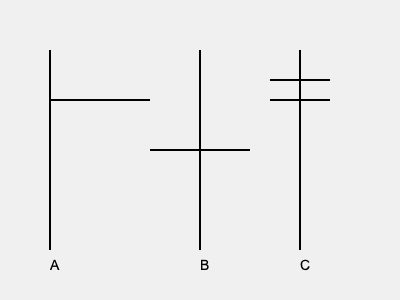In the image above, three different types of crosses are shown. Which of these crosses is most commonly associated with the sacrifice of Jesus Christ and is the primary symbol of Christianity? To answer this question, we need to examine each cross and its significance in Christianity:

1. Cross A: This is known as the Latin Cross or Christian Cross. It is the most common and widely recognized symbol of Christianity. The longer vertical beam represents the body of Christ, while the shorter horizontal beam represents His outstretched arms. This cross is directly associated with the crucifixion of Jesus and His sacrifice for humanity's sins.

2. Cross B: This is the Greek Cross, with equal-length arms. While it is used in Christianity, particularly in Greek Orthodox traditions, it is not as universally recognized as the primary symbol of Christ's sacrifice.

3. Cross C: This is the Papal Cross or Triple Cross. It has three horizontal bars of decreasing length from top to bottom. This cross is specifically associated with the Pope and the papacy, rather than being a general symbol for all of Christianity.

Given the question's focus on the cross most commonly associated with Christ's sacrifice and being the primary symbol of Christianity, the correct answer is Cross A, the Latin Cross.
Answer: Cross A (Latin Cross) 